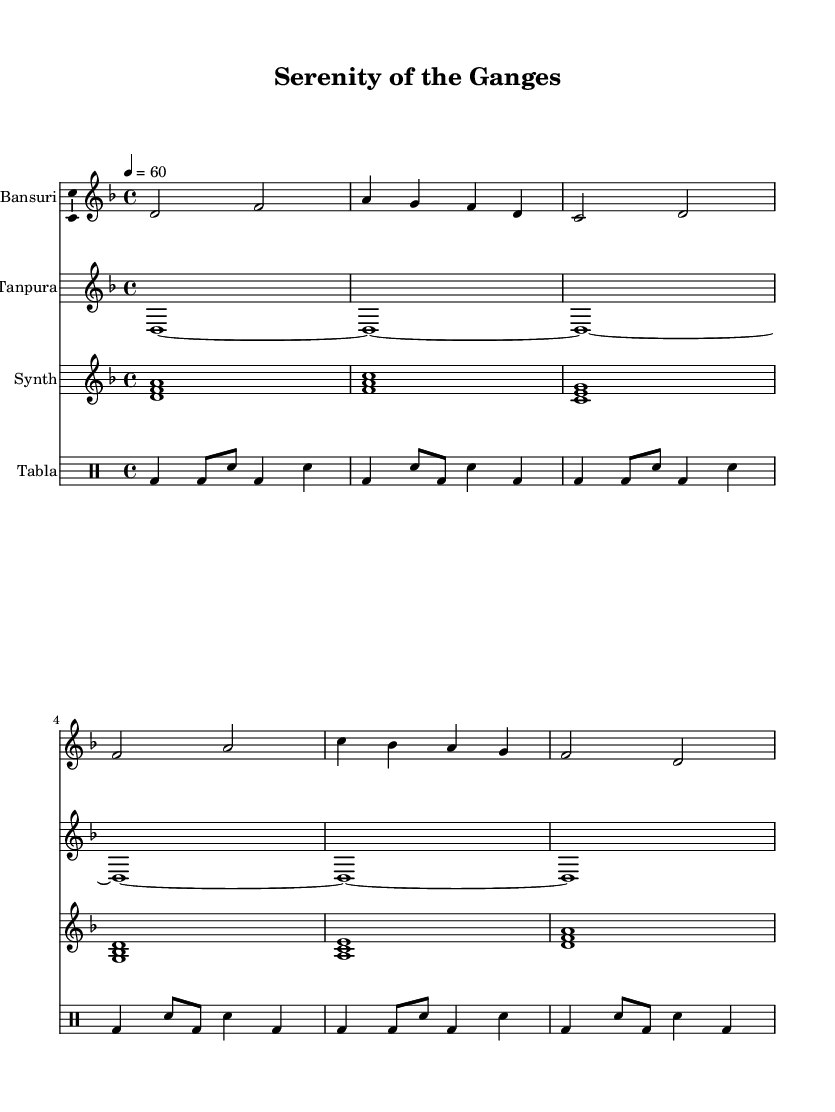What is the key signature of this music? The key signature indicated at the beginning of the piece is D minor, which typically has one flat (B flat). This can be determined from the "\key d \minor" command in the code.
Answer: D minor What is the time signature of this piece? The time signature is specified as 4/4, meaning there are four beats in each measure, and the quarter note gets one beat. This is shown with the "\time 4/4" command in the code.
Answer: 4/4 What is the tempo marking for this music? The tempo marking given in the score is "4 = 60," indicating that each quarter note gets 60 beats per minute. This is specified by the "\tempo" command in the code.
Answer: 60 Which instrument plays the sustained notes throughout the piece? The Tanpura is noted to play sustained tonic drones, as indicated in the score by the long held notes without breaks, shown in the "\set Staff.instrumentName = #"Tanpura"" section.
Answer: Tanpura How many unique instruments are used in this composition? The score features four unique instruments: Bansuri, Tanpura, Synth, and Tabla. Each one is defined in its own section of the code, thus amounting to four distinct parts in the composition.
Answer: Four What type of rhythm pattern is prominently used in the Tabla part? The rhythm pattern is characterized by alternating between bass and snare drum sounds, shown with a pattern of bass and snare beats in the "tabla" drummode section of the code. It repeats a similar structure in each measure.
Answer: Alternating bass and snare Which instrument is introduced to create harmonic layers in this ambient piece? The Synth serves to create harmonic layers, as seen in the synth section where chords are played together, enriching the overall sound texture of the piece that surrounds the melodic line from the Bansuri.
Answer: Synth 